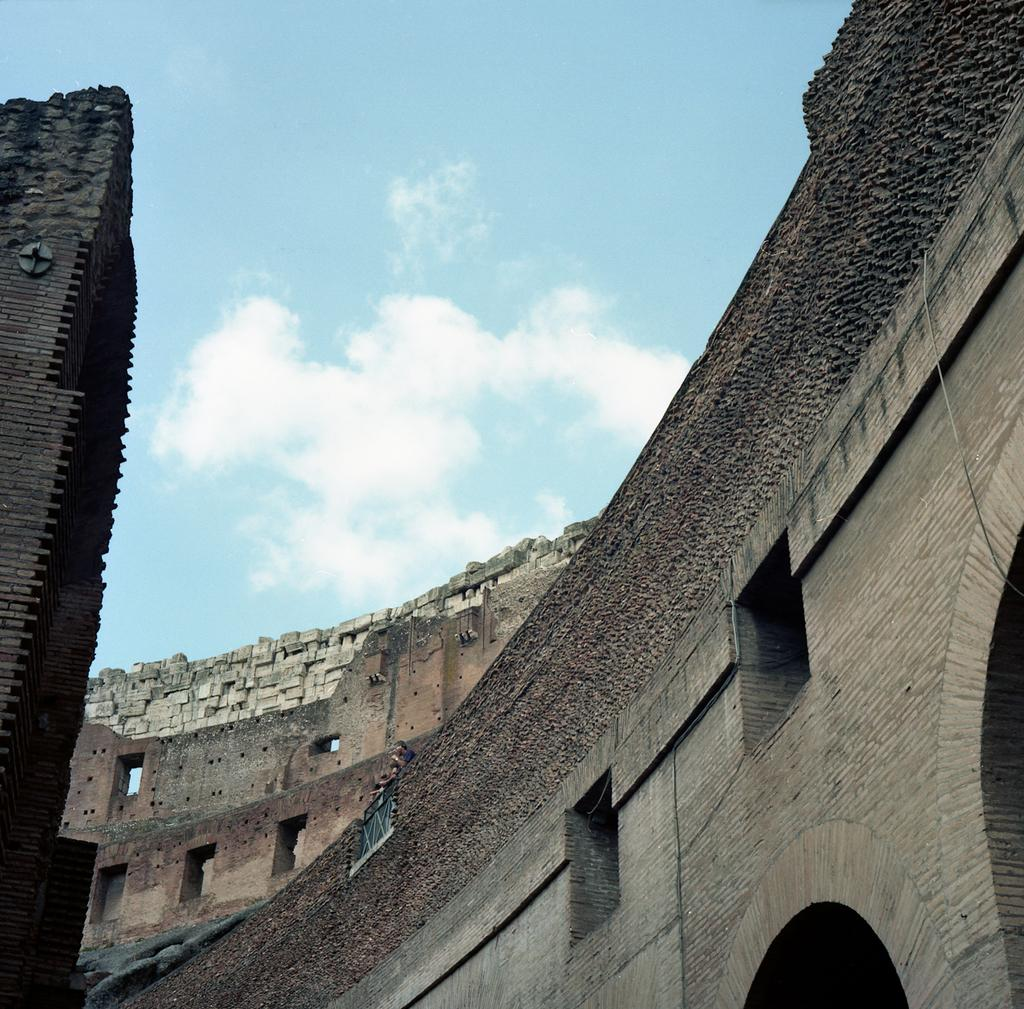What type of structure is present in the image? There is a building in the image. What can be seen in the sky at the top of the image? There are clouds visible in the sky at the top of the image. What type of whip is being used by the person in the image? There is no person or whip present in the image; it only features a building and clouds in the sky. 